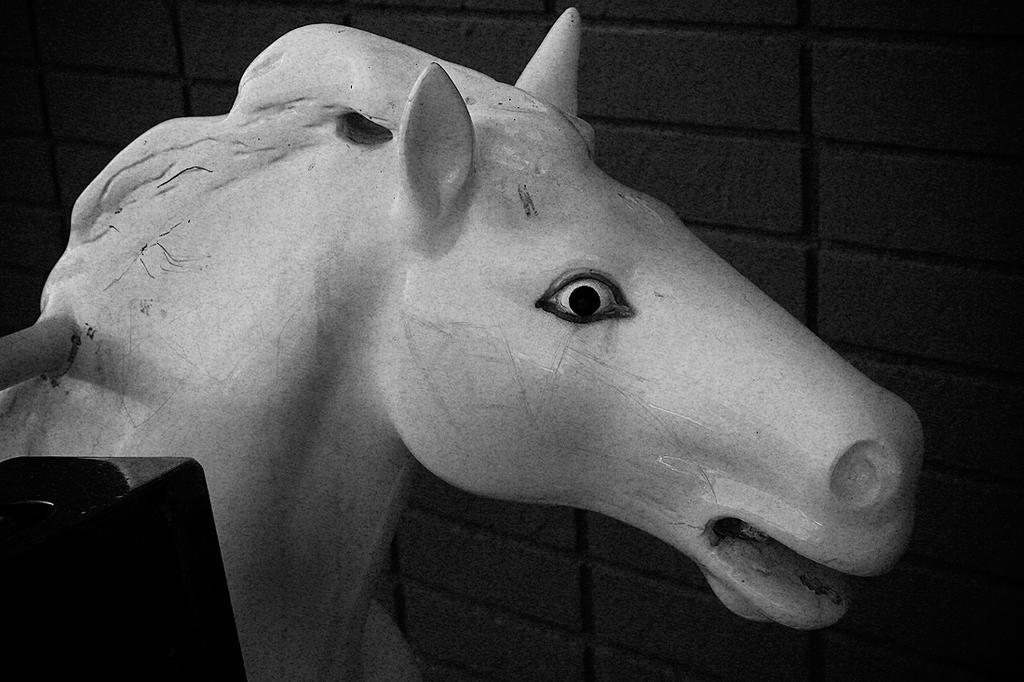Please provide a concise description of this image. In this picture there is a statue of an animal. In the foreground there is an object. At the back it looks like a wall. 